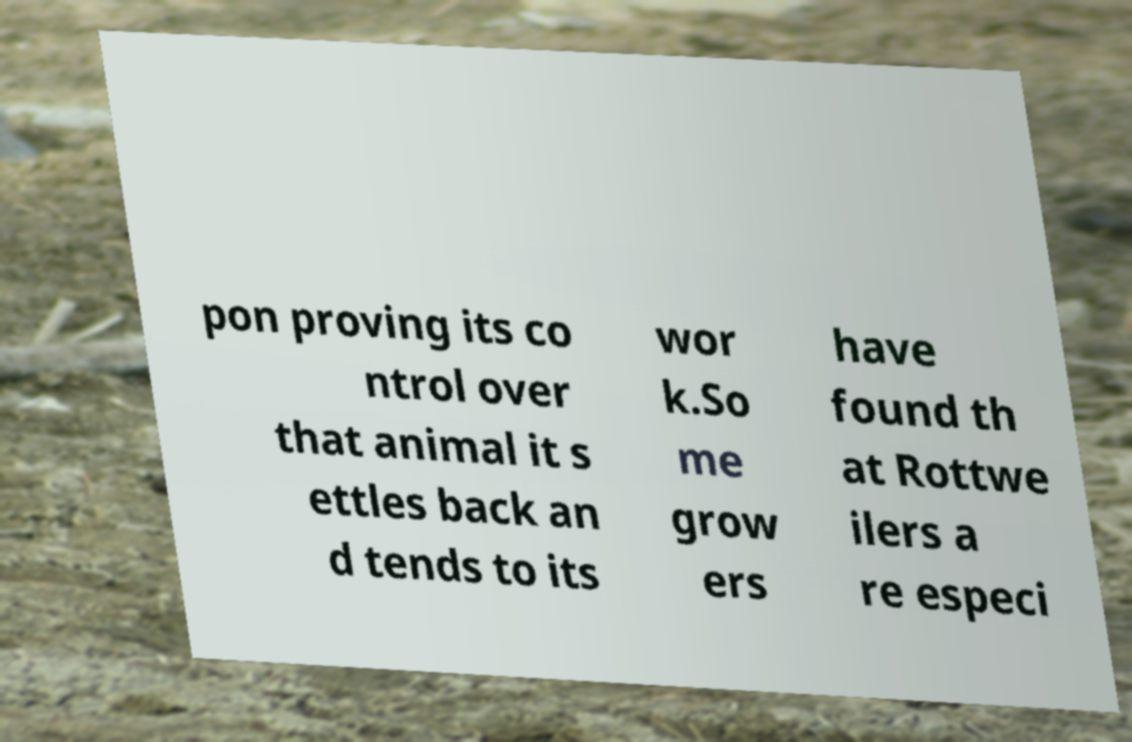For documentation purposes, I need the text within this image transcribed. Could you provide that? pon proving its co ntrol over that animal it s ettles back an d tends to its wor k.So me grow ers have found th at Rottwe ilers a re especi 